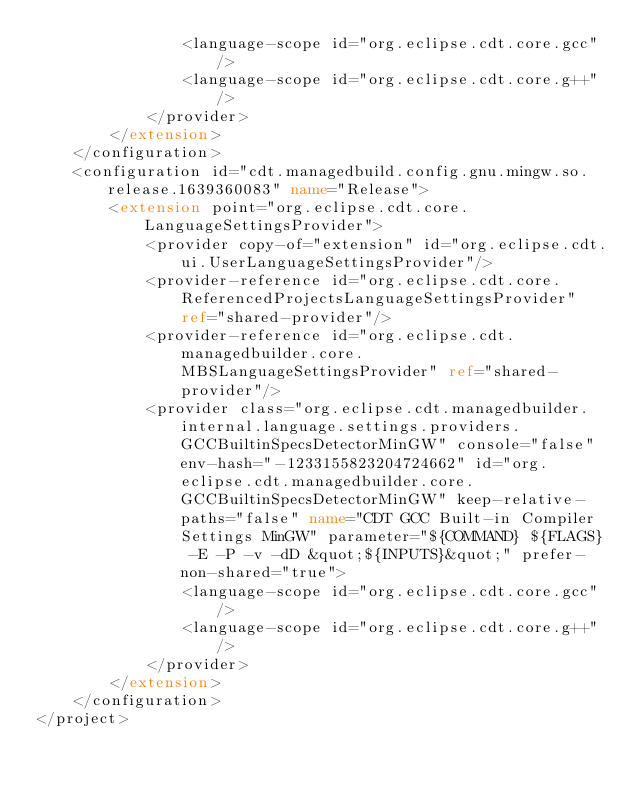<code> <loc_0><loc_0><loc_500><loc_500><_XML_>				<language-scope id="org.eclipse.cdt.core.gcc"/>
				<language-scope id="org.eclipse.cdt.core.g++"/>
			</provider>
		</extension>
	</configuration>
	<configuration id="cdt.managedbuild.config.gnu.mingw.so.release.1639360083" name="Release">
		<extension point="org.eclipse.cdt.core.LanguageSettingsProvider">
			<provider copy-of="extension" id="org.eclipse.cdt.ui.UserLanguageSettingsProvider"/>
			<provider-reference id="org.eclipse.cdt.core.ReferencedProjectsLanguageSettingsProvider" ref="shared-provider"/>
			<provider-reference id="org.eclipse.cdt.managedbuilder.core.MBSLanguageSettingsProvider" ref="shared-provider"/>
			<provider class="org.eclipse.cdt.managedbuilder.internal.language.settings.providers.GCCBuiltinSpecsDetectorMinGW" console="false" env-hash="-1233155823204724662" id="org.eclipse.cdt.managedbuilder.core.GCCBuiltinSpecsDetectorMinGW" keep-relative-paths="false" name="CDT GCC Built-in Compiler Settings MinGW" parameter="${COMMAND} ${FLAGS} -E -P -v -dD &quot;${INPUTS}&quot;" prefer-non-shared="true">
				<language-scope id="org.eclipse.cdt.core.gcc"/>
				<language-scope id="org.eclipse.cdt.core.g++"/>
			</provider>
		</extension>
	</configuration>
</project>
</code> 